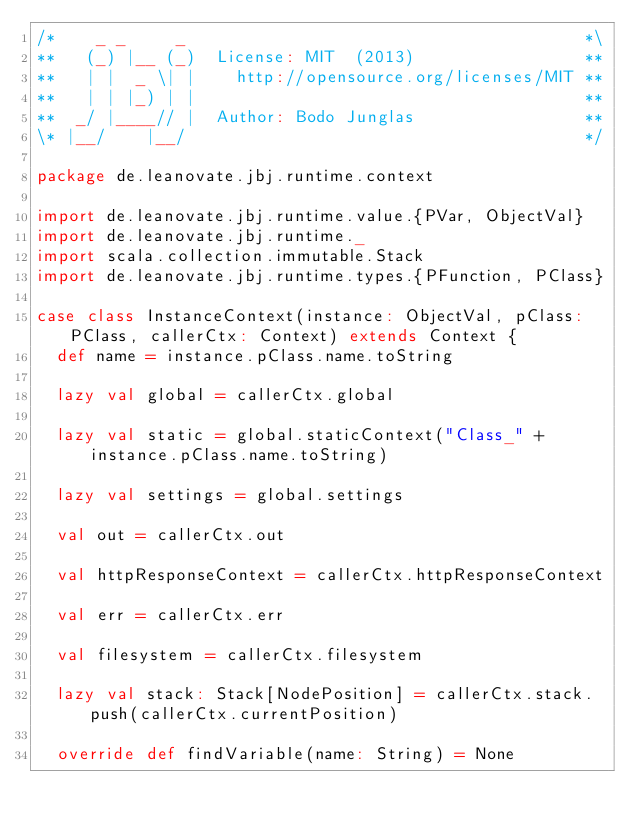<code> <loc_0><loc_0><loc_500><loc_500><_Scala_>/*    _ _     _                                        *\
**   (_) |__ (_)  License: MIT  (2013)                 **
**   | |  _ \| |    http://opensource.org/licenses/MIT **
**   | | |_) | |                                       **
**  _/ |____// |  Author: Bodo Junglas                 **
\* |__/    |__/                                        */

package de.leanovate.jbj.runtime.context

import de.leanovate.jbj.runtime.value.{PVar, ObjectVal}
import de.leanovate.jbj.runtime._
import scala.collection.immutable.Stack
import de.leanovate.jbj.runtime.types.{PFunction, PClass}

case class InstanceContext(instance: ObjectVal, pClass:PClass, callerCtx: Context) extends Context {
  def name = instance.pClass.name.toString

  lazy val global = callerCtx.global

  lazy val static = global.staticContext("Class_" + instance.pClass.name.toString)

  lazy val settings = global.settings

  val out = callerCtx.out

  val httpResponseContext = callerCtx.httpResponseContext

  val err = callerCtx.err

  val filesystem = callerCtx.filesystem

  lazy val stack: Stack[NodePosition] = callerCtx.stack.push(callerCtx.currentPosition)

  override def findVariable(name: String) = None
</code> 